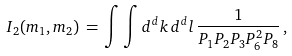Convert formula to latex. <formula><loc_0><loc_0><loc_500><loc_500>I _ { 2 } ( m _ { 1 } , m _ { 2 } ) \, = \, \int \int d ^ { d } k \, d ^ { d } l \, \frac { 1 } { P _ { 1 } P _ { 2 } P _ { 3 } P _ { 6 } ^ { 2 } P _ { 8 } } \, ,</formula> 